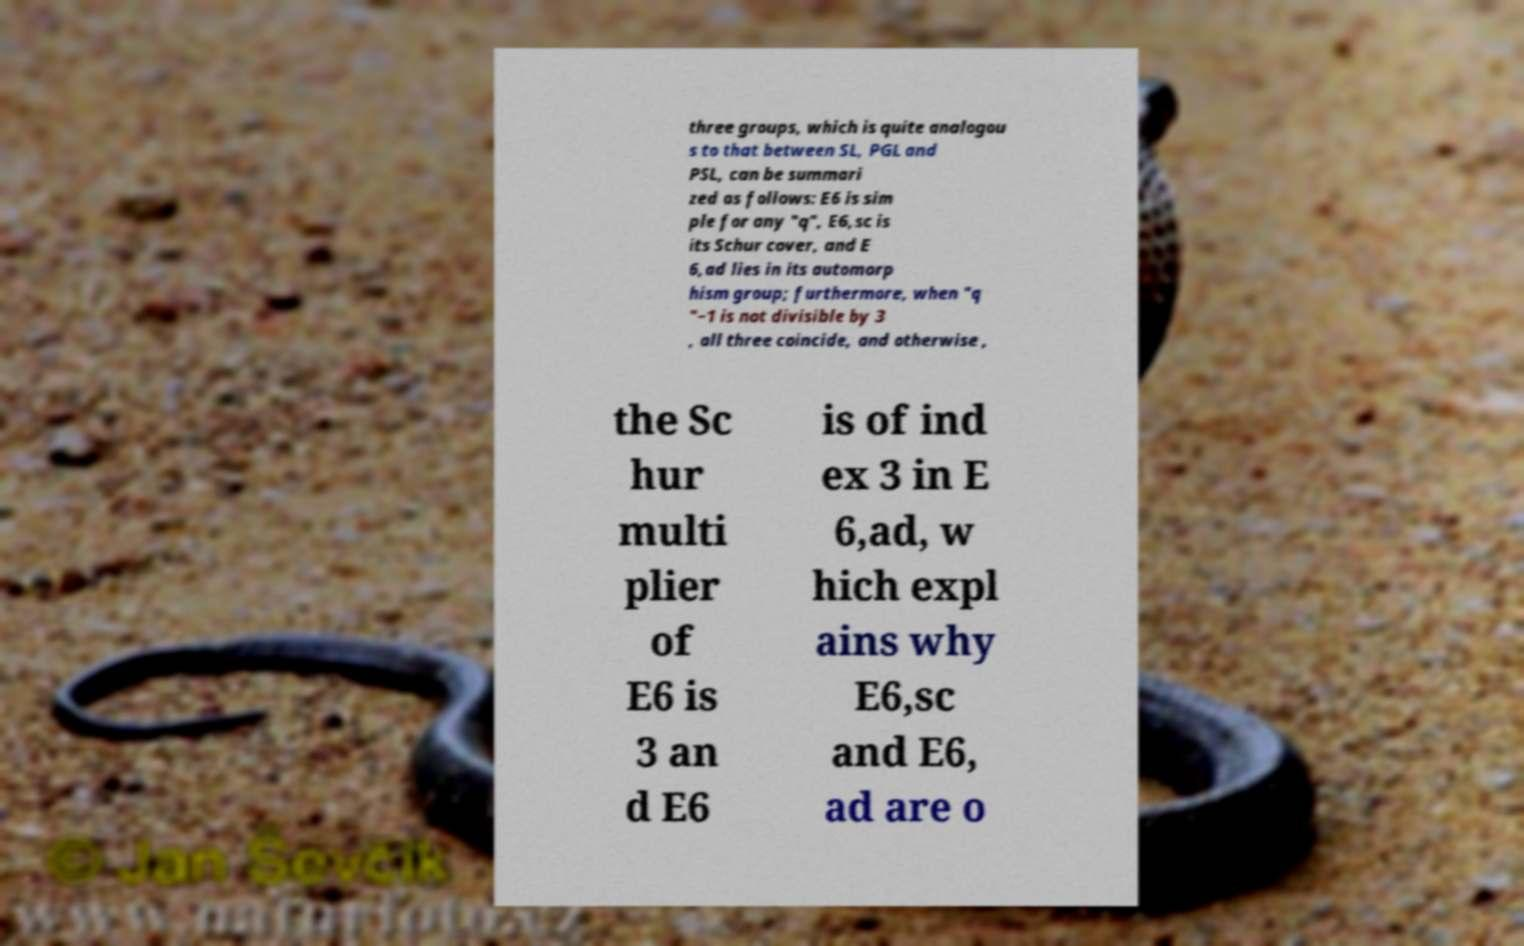I need the written content from this picture converted into text. Can you do that? three groups, which is quite analogou s to that between SL, PGL and PSL, can be summari zed as follows: E6 is sim ple for any "q", E6,sc is its Schur cover, and E 6,ad lies in its automorp hism group; furthermore, when "q "−1 is not divisible by 3 , all three coincide, and otherwise , the Sc hur multi plier of E6 is 3 an d E6 is of ind ex 3 in E 6,ad, w hich expl ains why E6,sc and E6, ad are o 